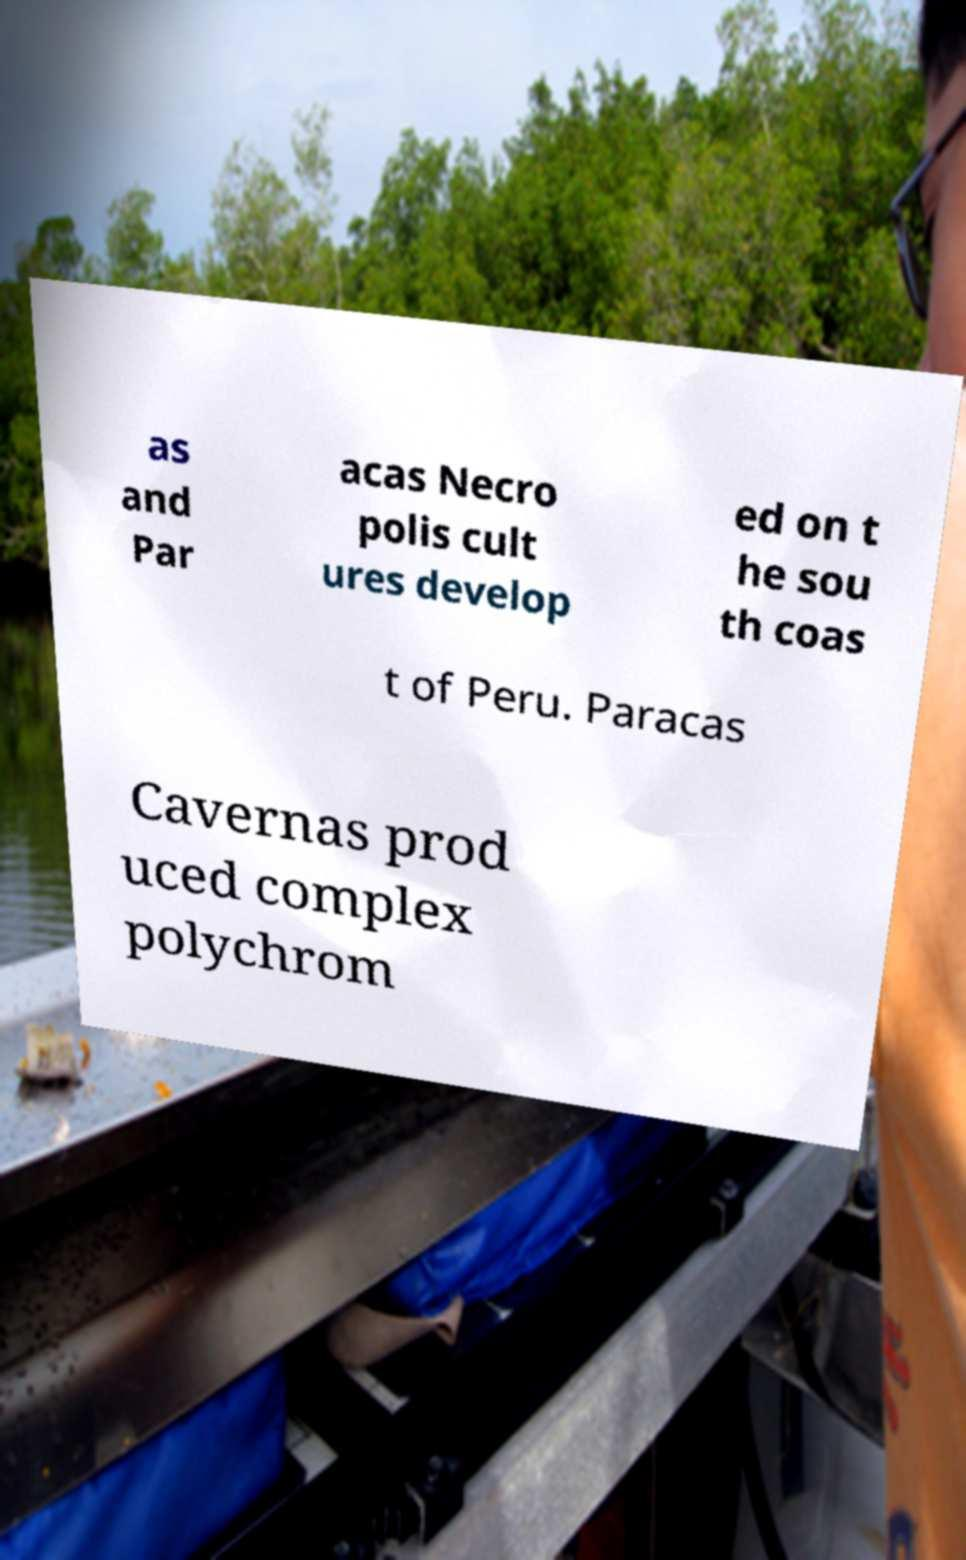Please read and relay the text visible in this image. What does it say? as and Par acas Necro polis cult ures develop ed on t he sou th coas t of Peru. Paracas Cavernas prod uced complex polychrom 